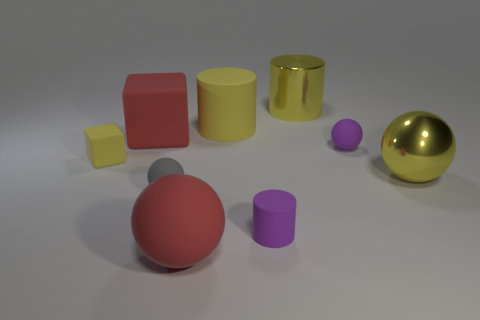Which objects are closest to the gold sphere? The small yellow cube and the silver sphere are closest to the gold sphere. Does the size of the silver sphere compare to any other objects? Yes, the silver sphere is similar in size to the purple sphere and the small purple cylinder. 